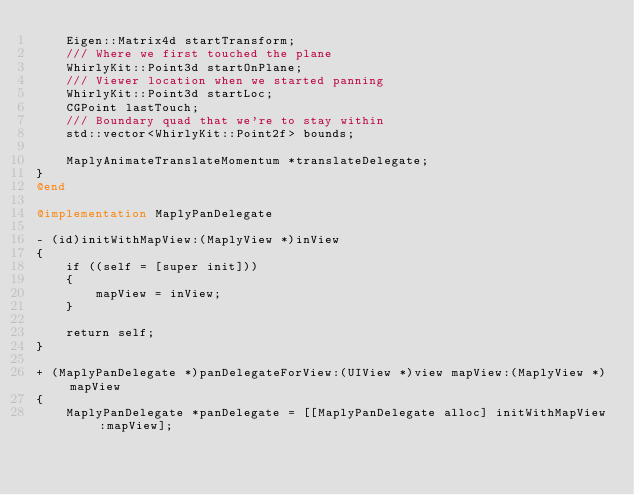Convert code to text. <code><loc_0><loc_0><loc_500><loc_500><_ObjectiveC_>    Eigen::Matrix4d startTransform;
    /// Where we first touched the plane
    WhirlyKit::Point3d startOnPlane;
    /// Viewer location when we started panning
    WhirlyKit::Point3d startLoc;
    CGPoint lastTouch;
    /// Boundary quad that we're to stay within
    std::vector<WhirlyKit::Point2f> bounds;

    MaplyAnimateTranslateMomentum *translateDelegate;
}
@end

@implementation MaplyPanDelegate

- (id)initWithMapView:(MaplyView *)inView
{
	if ((self = [super init]))
	{
		mapView = inView;
	}
	
	return self;
}

+ (MaplyPanDelegate *)panDelegateForView:(UIView *)view mapView:(MaplyView *)mapView
{
	MaplyPanDelegate *panDelegate = [[MaplyPanDelegate alloc] initWithMapView:mapView];</code> 